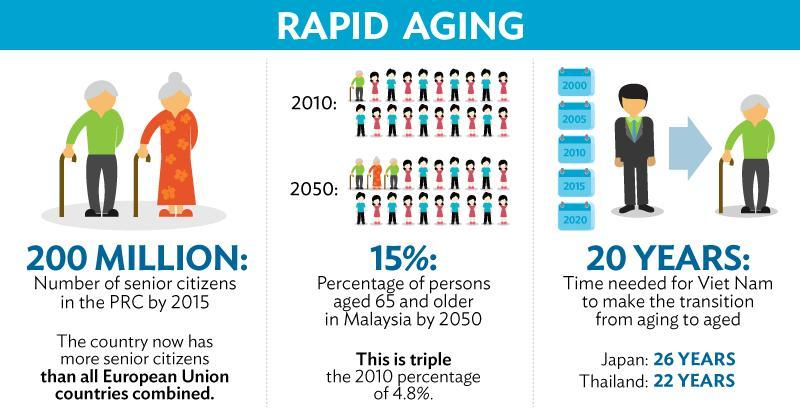What is the number of senior citizens in the PCR by 2015?
Answer the question with a short phrase. 200 Million 